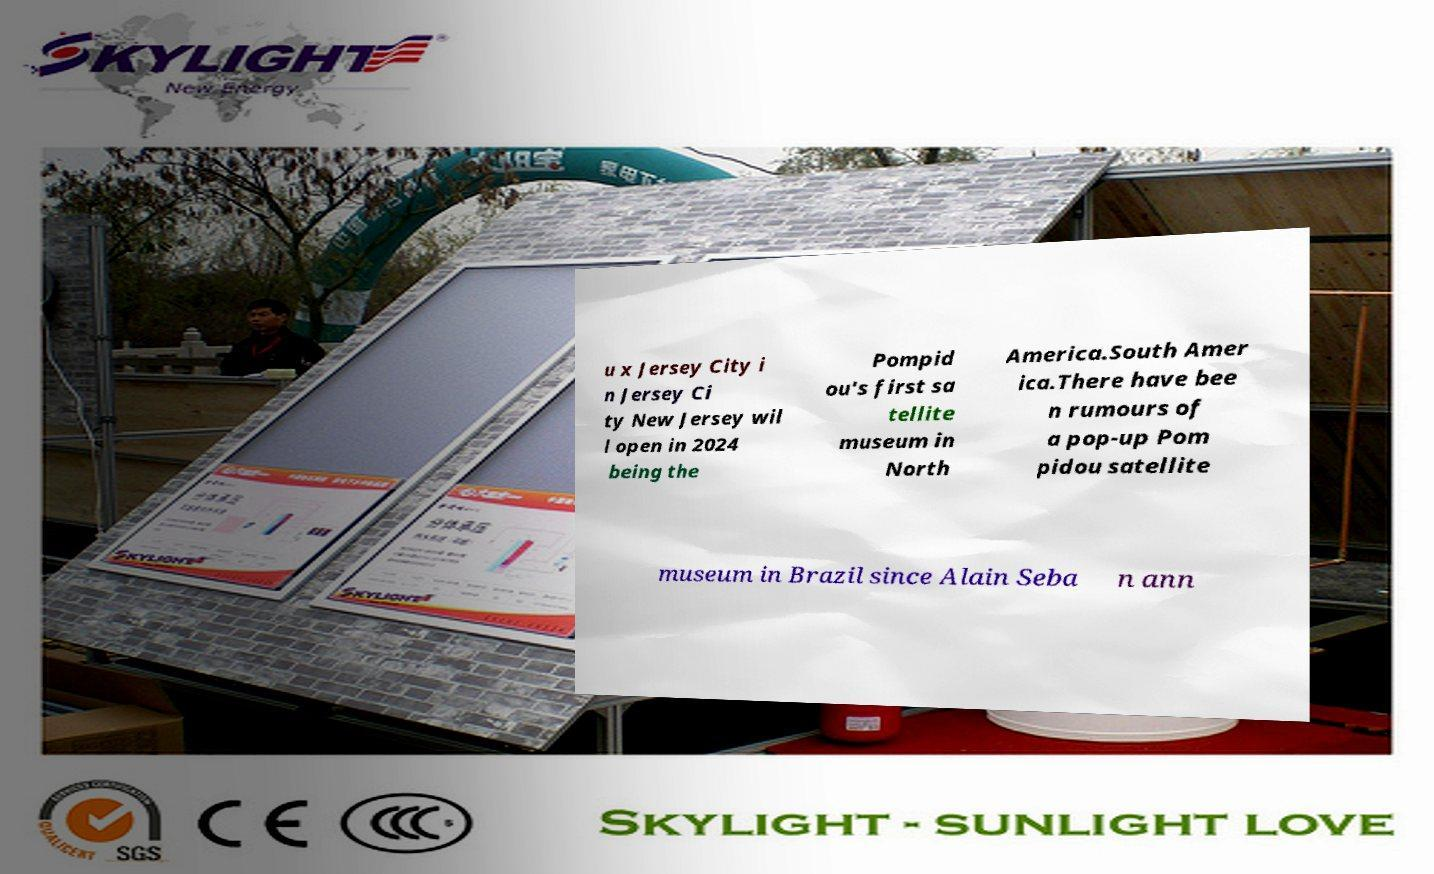What messages or text are displayed in this image? I need them in a readable, typed format. u x Jersey City i n Jersey Ci ty New Jersey wil l open in 2024 being the Pompid ou's first sa tellite museum in North America.South Amer ica.There have bee n rumours of a pop-up Pom pidou satellite museum in Brazil since Alain Seba n ann 